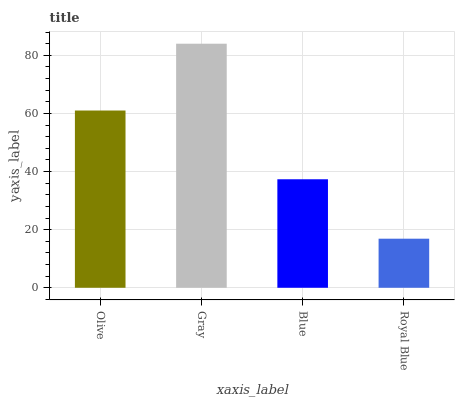Is Blue the minimum?
Answer yes or no. No. Is Blue the maximum?
Answer yes or no. No. Is Gray greater than Blue?
Answer yes or no. Yes. Is Blue less than Gray?
Answer yes or no. Yes. Is Blue greater than Gray?
Answer yes or no. No. Is Gray less than Blue?
Answer yes or no. No. Is Olive the high median?
Answer yes or no. Yes. Is Blue the low median?
Answer yes or no. Yes. Is Royal Blue the high median?
Answer yes or no. No. Is Olive the low median?
Answer yes or no. No. 